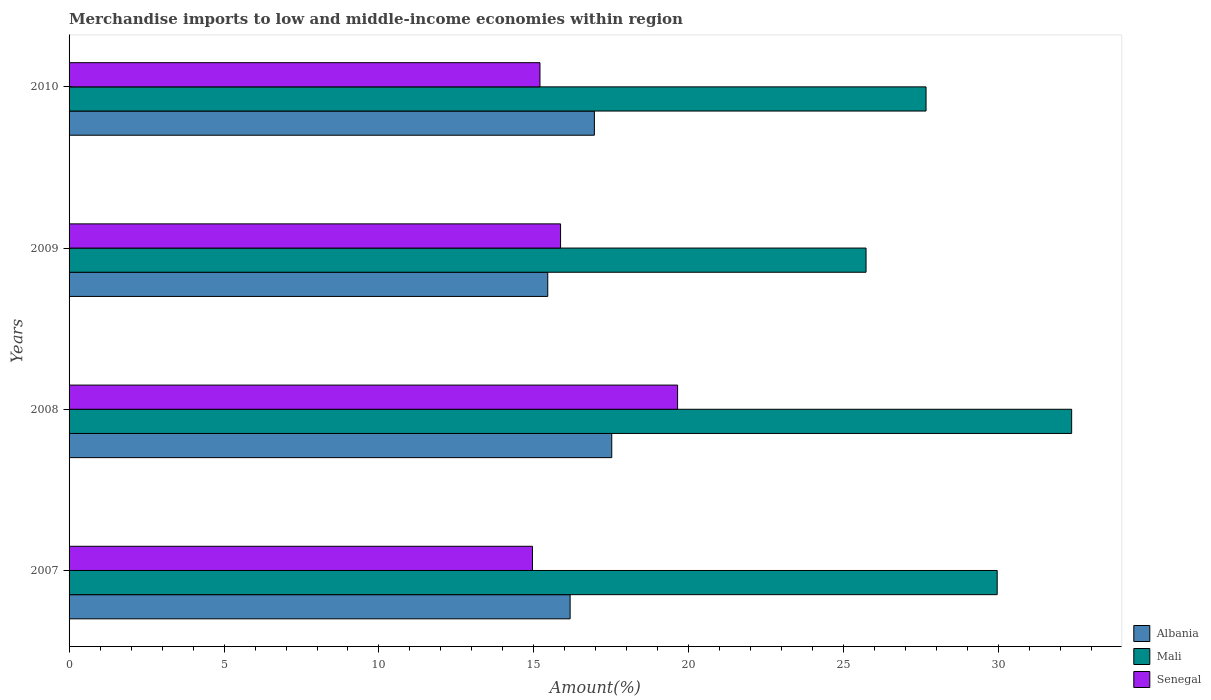How many groups of bars are there?
Your answer should be very brief. 4. Are the number of bars per tick equal to the number of legend labels?
Keep it short and to the point. Yes. What is the percentage of amount earned from merchandise imports in Albania in 2009?
Your answer should be very brief. 15.45. Across all years, what is the maximum percentage of amount earned from merchandise imports in Albania?
Offer a very short reply. 17.51. Across all years, what is the minimum percentage of amount earned from merchandise imports in Albania?
Your answer should be very brief. 15.45. What is the total percentage of amount earned from merchandise imports in Mali in the graph?
Offer a very short reply. 115.67. What is the difference between the percentage of amount earned from merchandise imports in Mali in 2007 and that in 2008?
Your response must be concise. -2.4. What is the difference between the percentage of amount earned from merchandise imports in Albania in 2010 and the percentage of amount earned from merchandise imports in Mali in 2008?
Give a very brief answer. -15.4. What is the average percentage of amount earned from merchandise imports in Mali per year?
Offer a terse response. 28.92. In the year 2008, what is the difference between the percentage of amount earned from merchandise imports in Mali and percentage of amount earned from merchandise imports in Albania?
Give a very brief answer. 14.84. What is the ratio of the percentage of amount earned from merchandise imports in Mali in 2007 to that in 2009?
Keep it short and to the point. 1.16. Is the percentage of amount earned from merchandise imports in Mali in 2007 less than that in 2010?
Your response must be concise. No. Is the difference between the percentage of amount earned from merchandise imports in Mali in 2008 and 2010 greater than the difference between the percentage of amount earned from merchandise imports in Albania in 2008 and 2010?
Provide a short and direct response. Yes. What is the difference between the highest and the second highest percentage of amount earned from merchandise imports in Mali?
Ensure brevity in your answer.  2.4. What is the difference between the highest and the lowest percentage of amount earned from merchandise imports in Senegal?
Your answer should be very brief. 4.68. In how many years, is the percentage of amount earned from merchandise imports in Senegal greater than the average percentage of amount earned from merchandise imports in Senegal taken over all years?
Offer a terse response. 1. Is the sum of the percentage of amount earned from merchandise imports in Senegal in 2008 and 2010 greater than the maximum percentage of amount earned from merchandise imports in Mali across all years?
Give a very brief answer. Yes. What does the 3rd bar from the top in 2008 represents?
Provide a short and direct response. Albania. What does the 3rd bar from the bottom in 2009 represents?
Give a very brief answer. Senegal. Are all the bars in the graph horizontal?
Make the answer very short. Yes. Does the graph contain grids?
Your answer should be compact. No. Where does the legend appear in the graph?
Offer a very short reply. Bottom right. How are the legend labels stacked?
Your response must be concise. Vertical. What is the title of the graph?
Make the answer very short. Merchandise imports to low and middle-income economies within region. Does "Isle of Man" appear as one of the legend labels in the graph?
Give a very brief answer. No. What is the label or title of the X-axis?
Keep it short and to the point. Amount(%). What is the label or title of the Y-axis?
Give a very brief answer. Years. What is the Amount(%) in Albania in 2007?
Provide a succinct answer. 16.17. What is the Amount(%) of Mali in 2007?
Keep it short and to the point. 29.95. What is the Amount(%) of Senegal in 2007?
Your answer should be compact. 14.95. What is the Amount(%) in Albania in 2008?
Offer a very short reply. 17.51. What is the Amount(%) of Mali in 2008?
Your answer should be compact. 32.35. What is the Amount(%) of Senegal in 2008?
Your response must be concise. 19.64. What is the Amount(%) of Albania in 2009?
Ensure brevity in your answer.  15.45. What is the Amount(%) in Mali in 2009?
Ensure brevity in your answer.  25.72. What is the Amount(%) of Senegal in 2009?
Offer a terse response. 15.86. What is the Amount(%) of Albania in 2010?
Offer a terse response. 16.95. What is the Amount(%) of Mali in 2010?
Provide a short and direct response. 27.65. What is the Amount(%) of Senegal in 2010?
Provide a short and direct response. 15.19. Across all years, what is the maximum Amount(%) of Albania?
Keep it short and to the point. 17.51. Across all years, what is the maximum Amount(%) in Mali?
Offer a very short reply. 32.35. Across all years, what is the maximum Amount(%) in Senegal?
Keep it short and to the point. 19.64. Across all years, what is the minimum Amount(%) of Albania?
Give a very brief answer. 15.45. Across all years, what is the minimum Amount(%) of Mali?
Ensure brevity in your answer.  25.72. Across all years, what is the minimum Amount(%) of Senegal?
Offer a very short reply. 14.95. What is the total Amount(%) in Albania in the graph?
Provide a succinct answer. 66.08. What is the total Amount(%) in Mali in the graph?
Keep it short and to the point. 115.67. What is the total Amount(%) of Senegal in the graph?
Ensure brevity in your answer.  65.64. What is the difference between the Amount(%) of Albania in 2007 and that in 2008?
Make the answer very short. -1.34. What is the difference between the Amount(%) of Mali in 2007 and that in 2008?
Offer a very short reply. -2.4. What is the difference between the Amount(%) in Senegal in 2007 and that in 2008?
Provide a short and direct response. -4.68. What is the difference between the Amount(%) of Albania in 2007 and that in 2009?
Provide a succinct answer. 0.72. What is the difference between the Amount(%) in Mali in 2007 and that in 2009?
Ensure brevity in your answer.  4.23. What is the difference between the Amount(%) in Senegal in 2007 and that in 2009?
Ensure brevity in your answer.  -0.91. What is the difference between the Amount(%) of Albania in 2007 and that in 2010?
Ensure brevity in your answer.  -0.78. What is the difference between the Amount(%) of Mali in 2007 and that in 2010?
Your answer should be very brief. 2.3. What is the difference between the Amount(%) of Senegal in 2007 and that in 2010?
Provide a succinct answer. -0.24. What is the difference between the Amount(%) of Albania in 2008 and that in 2009?
Your answer should be very brief. 2.07. What is the difference between the Amount(%) of Mali in 2008 and that in 2009?
Your answer should be very brief. 6.63. What is the difference between the Amount(%) of Senegal in 2008 and that in 2009?
Provide a short and direct response. 3.78. What is the difference between the Amount(%) in Albania in 2008 and that in 2010?
Provide a short and direct response. 0.56. What is the difference between the Amount(%) in Mali in 2008 and that in 2010?
Give a very brief answer. 4.7. What is the difference between the Amount(%) in Senegal in 2008 and that in 2010?
Give a very brief answer. 4.44. What is the difference between the Amount(%) in Albania in 2009 and that in 2010?
Make the answer very short. -1.5. What is the difference between the Amount(%) of Mali in 2009 and that in 2010?
Ensure brevity in your answer.  -1.94. What is the difference between the Amount(%) in Senegal in 2009 and that in 2010?
Offer a terse response. 0.66. What is the difference between the Amount(%) of Albania in 2007 and the Amount(%) of Mali in 2008?
Offer a very short reply. -16.18. What is the difference between the Amount(%) of Albania in 2007 and the Amount(%) of Senegal in 2008?
Give a very brief answer. -3.47. What is the difference between the Amount(%) of Mali in 2007 and the Amount(%) of Senegal in 2008?
Provide a short and direct response. 10.31. What is the difference between the Amount(%) of Albania in 2007 and the Amount(%) of Mali in 2009?
Offer a terse response. -9.55. What is the difference between the Amount(%) of Albania in 2007 and the Amount(%) of Senegal in 2009?
Your answer should be compact. 0.31. What is the difference between the Amount(%) in Mali in 2007 and the Amount(%) in Senegal in 2009?
Provide a short and direct response. 14.09. What is the difference between the Amount(%) of Albania in 2007 and the Amount(%) of Mali in 2010?
Provide a succinct answer. -11.48. What is the difference between the Amount(%) of Albania in 2007 and the Amount(%) of Senegal in 2010?
Make the answer very short. 0.97. What is the difference between the Amount(%) of Mali in 2007 and the Amount(%) of Senegal in 2010?
Offer a very short reply. 14.75. What is the difference between the Amount(%) in Albania in 2008 and the Amount(%) in Mali in 2009?
Your response must be concise. -8.21. What is the difference between the Amount(%) of Albania in 2008 and the Amount(%) of Senegal in 2009?
Offer a terse response. 1.65. What is the difference between the Amount(%) of Mali in 2008 and the Amount(%) of Senegal in 2009?
Provide a succinct answer. 16.49. What is the difference between the Amount(%) of Albania in 2008 and the Amount(%) of Mali in 2010?
Offer a very short reply. -10.14. What is the difference between the Amount(%) of Albania in 2008 and the Amount(%) of Senegal in 2010?
Ensure brevity in your answer.  2.32. What is the difference between the Amount(%) in Mali in 2008 and the Amount(%) in Senegal in 2010?
Offer a terse response. 17.16. What is the difference between the Amount(%) in Albania in 2009 and the Amount(%) in Mali in 2010?
Offer a terse response. -12.21. What is the difference between the Amount(%) in Albania in 2009 and the Amount(%) in Senegal in 2010?
Your answer should be very brief. 0.25. What is the difference between the Amount(%) of Mali in 2009 and the Amount(%) of Senegal in 2010?
Ensure brevity in your answer.  10.52. What is the average Amount(%) of Albania per year?
Offer a very short reply. 16.52. What is the average Amount(%) in Mali per year?
Your answer should be compact. 28.92. What is the average Amount(%) in Senegal per year?
Give a very brief answer. 16.41. In the year 2007, what is the difference between the Amount(%) of Albania and Amount(%) of Mali?
Offer a very short reply. -13.78. In the year 2007, what is the difference between the Amount(%) in Albania and Amount(%) in Senegal?
Your response must be concise. 1.22. In the year 2007, what is the difference between the Amount(%) in Mali and Amount(%) in Senegal?
Your answer should be compact. 15. In the year 2008, what is the difference between the Amount(%) of Albania and Amount(%) of Mali?
Offer a very short reply. -14.84. In the year 2008, what is the difference between the Amount(%) in Albania and Amount(%) in Senegal?
Make the answer very short. -2.12. In the year 2008, what is the difference between the Amount(%) of Mali and Amount(%) of Senegal?
Your answer should be compact. 12.72. In the year 2009, what is the difference between the Amount(%) of Albania and Amount(%) of Mali?
Ensure brevity in your answer.  -10.27. In the year 2009, what is the difference between the Amount(%) of Albania and Amount(%) of Senegal?
Give a very brief answer. -0.41. In the year 2009, what is the difference between the Amount(%) in Mali and Amount(%) in Senegal?
Your answer should be very brief. 9.86. In the year 2010, what is the difference between the Amount(%) of Albania and Amount(%) of Mali?
Ensure brevity in your answer.  -10.7. In the year 2010, what is the difference between the Amount(%) of Albania and Amount(%) of Senegal?
Your answer should be compact. 1.76. In the year 2010, what is the difference between the Amount(%) in Mali and Amount(%) in Senegal?
Make the answer very short. 12.46. What is the ratio of the Amount(%) in Albania in 2007 to that in 2008?
Ensure brevity in your answer.  0.92. What is the ratio of the Amount(%) in Mali in 2007 to that in 2008?
Offer a very short reply. 0.93. What is the ratio of the Amount(%) of Senegal in 2007 to that in 2008?
Provide a succinct answer. 0.76. What is the ratio of the Amount(%) of Albania in 2007 to that in 2009?
Your response must be concise. 1.05. What is the ratio of the Amount(%) in Mali in 2007 to that in 2009?
Your answer should be very brief. 1.16. What is the ratio of the Amount(%) in Senegal in 2007 to that in 2009?
Offer a terse response. 0.94. What is the ratio of the Amount(%) of Albania in 2007 to that in 2010?
Keep it short and to the point. 0.95. What is the ratio of the Amount(%) in Mali in 2007 to that in 2010?
Your answer should be very brief. 1.08. What is the ratio of the Amount(%) in Senegal in 2007 to that in 2010?
Ensure brevity in your answer.  0.98. What is the ratio of the Amount(%) of Albania in 2008 to that in 2009?
Keep it short and to the point. 1.13. What is the ratio of the Amount(%) in Mali in 2008 to that in 2009?
Your response must be concise. 1.26. What is the ratio of the Amount(%) of Senegal in 2008 to that in 2009?
Keep it short and to the point. 1.24. What is the ratio of the Amount(%) of Albania in 2008 to that in 2010?
Your response must be concise. 1.03. What is the ratio of the Amount(%) of Mali in 2008 to that in 2010?
Provide a short and direct response. 1.17. What is the ratio of the Amount(%) of Senegal in 2008 to that in 2010?
Ensure brevity in your answer.  1.29. What is the ratio of the Amount(%) of Albania in 2009 to that in 2010?
Offer a terse response. 0.91. What is the ratio of the Amount(%) in Mali in 2009 to that in 2010?
Provide a short and direct response. 0.93. What is the ratio of the Amount(%) of Senegal in 2009 to that in 2010?
Provide a succinct answer. 1.04. What is the difference between the highest and the second highest Amount(%) in Albania?
Your response must be concise. 0.56. What is the difference between the highest and the second highest Amount(%) of Mali?
Ensure brevity in your answer.  2.4. What is the difference between the highest and the second highest Amount(%) of Senegal?
Your answer should be very brief. 3.78. What is the difference between the highest and the lowest Amount(%) in Albania?
Give a very brief answer. 2.07. What is the difference between the highest and the lowest Amount(%) of Mali?
Offer a very short reply. 6.63. What is the difference between the highest and the lowest Amount(%) of Senegal?
Offer a very short reply. 4.68. 